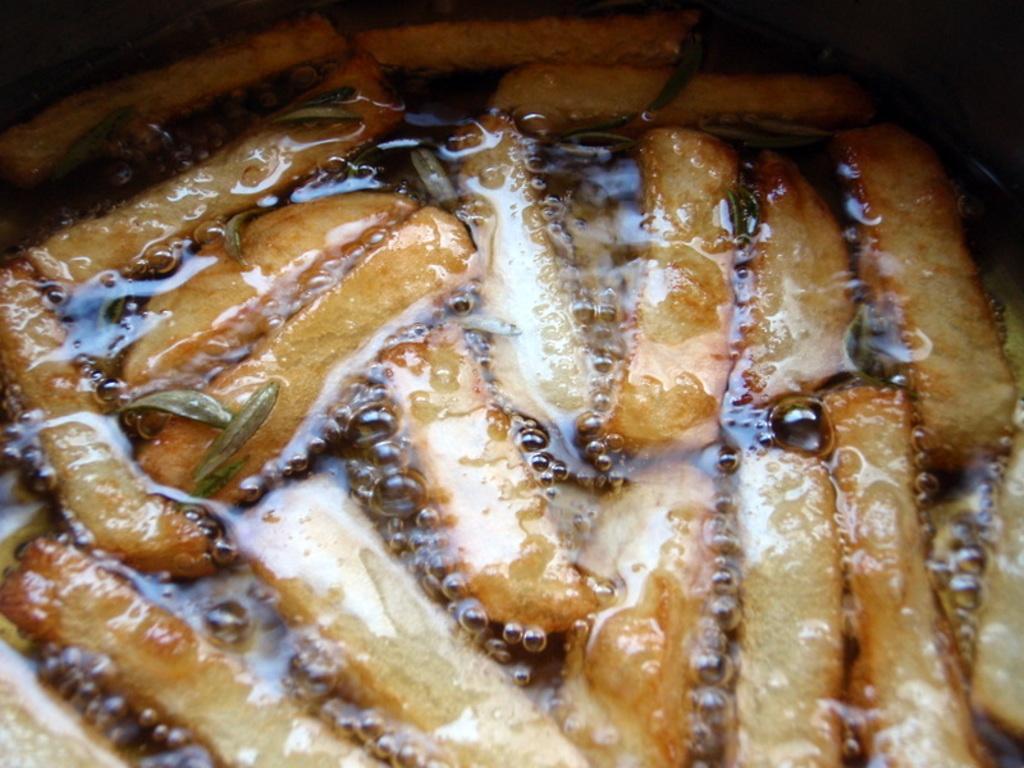Describe this image in one or two sentences. In this picture we can see food, oil and in the background we can see it is dark. 